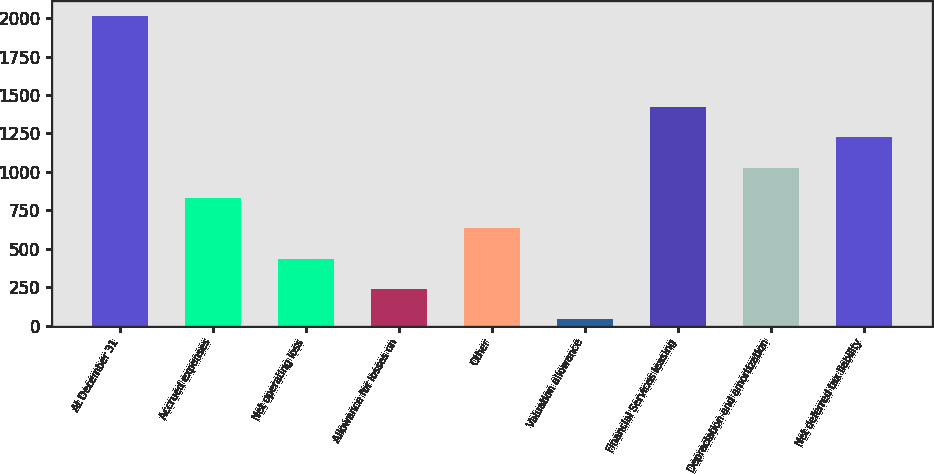Convert chart to OTSL. <chart><loc_0><loc_0><loc_500><loc_500><bar_chart><fcel>At December 31<fcel>Accrued expenses<fcel>Net operating loss<fcel>Allowance for losses on<fcel>Other<fcel>Valuation allowance<fcel>Financial Services leasing<fcel>Depreciation and amortization<fcel>Net deferred tax liability<nl><fcel>2013<fcel>831.54<fcel>437.72<fcel>240.81<fcel>634.63<fcel>43.9<fcel>1422.27<fcel>1028.45<fcel>1225.36<nl></chart> 